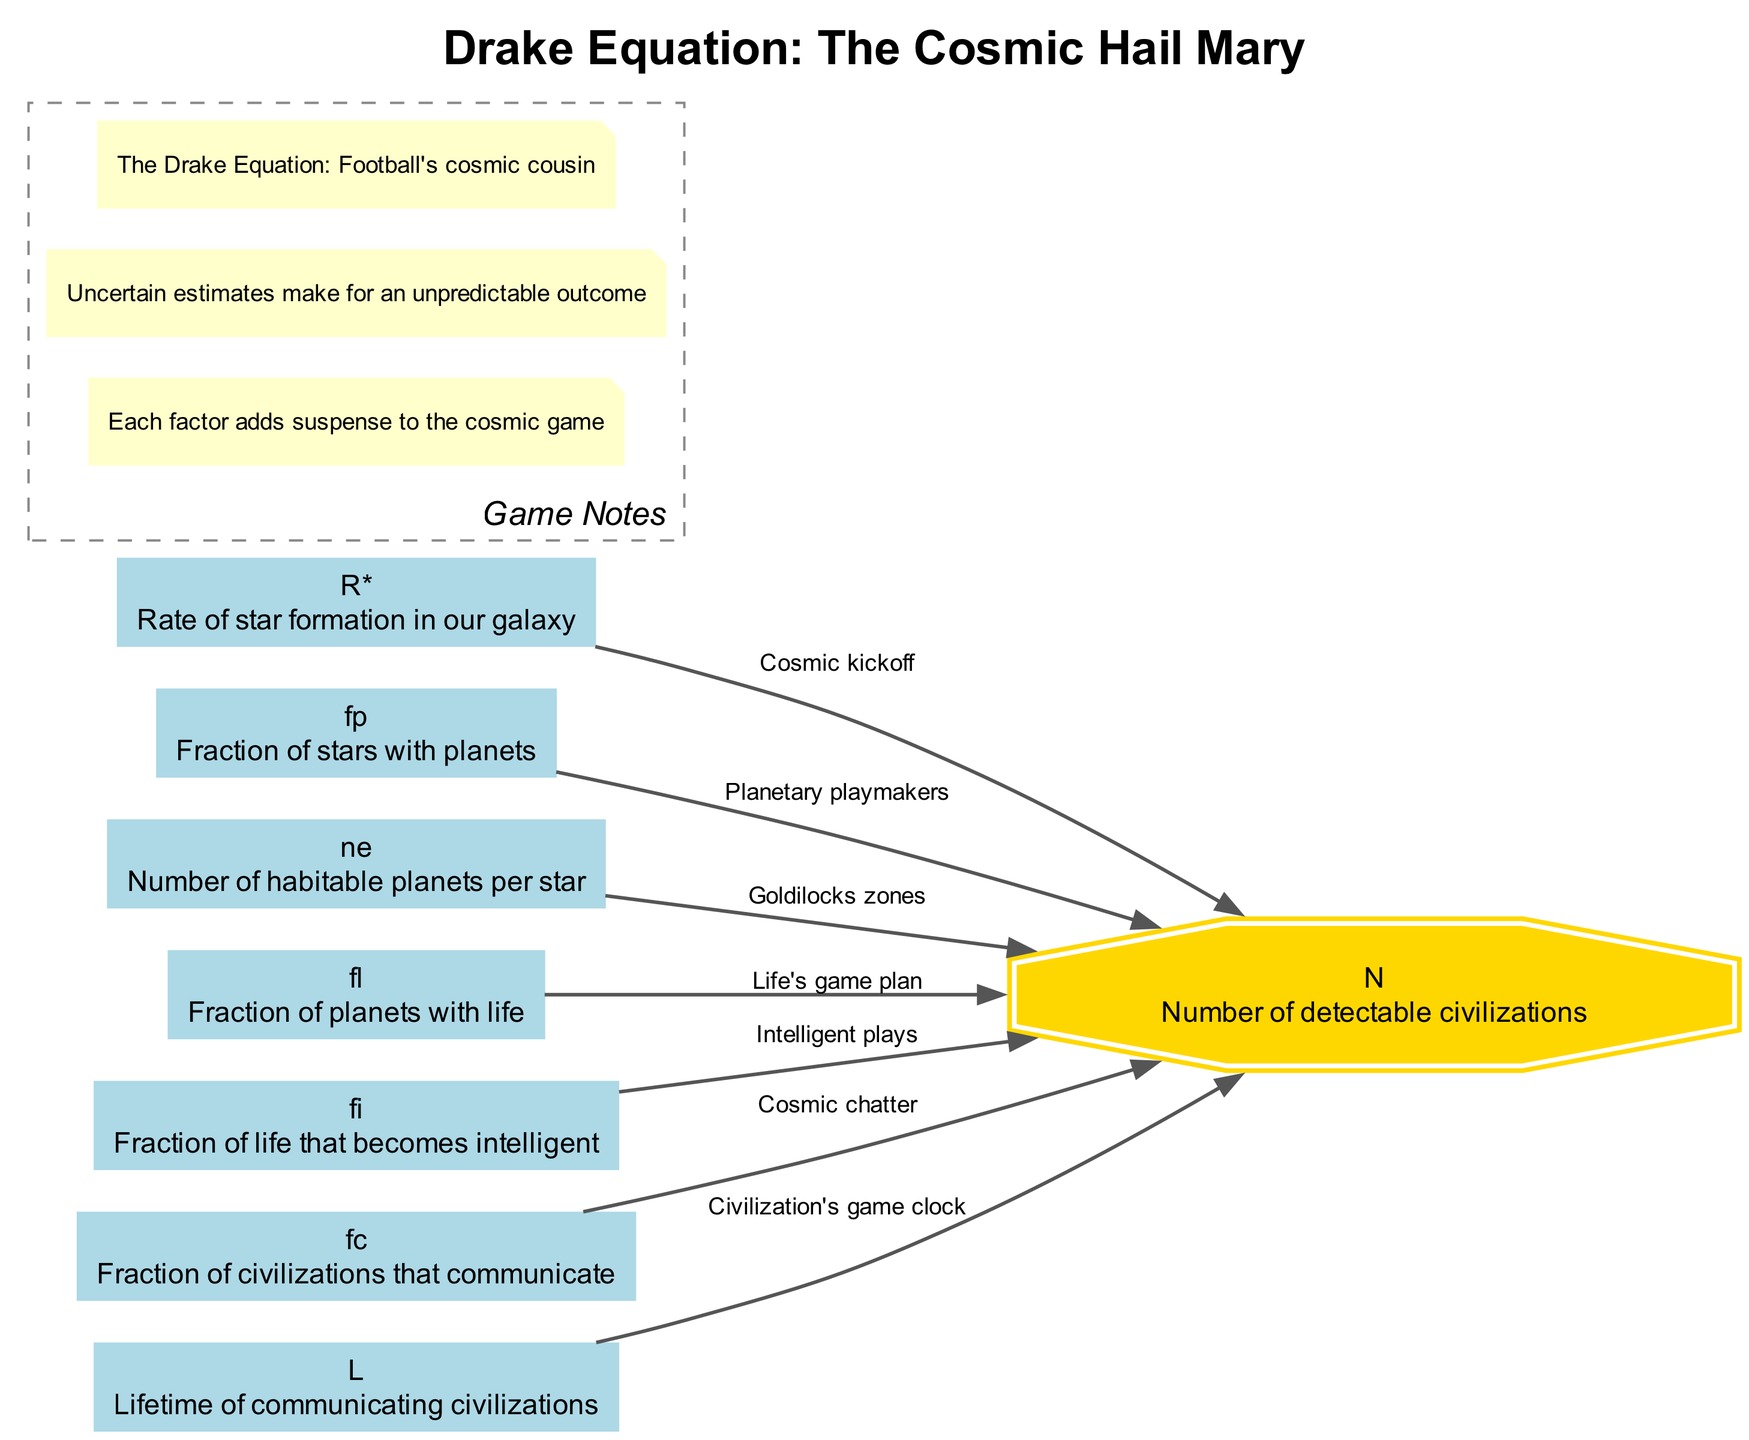What is the abbreviation for the rate of star formation in our galaxy? The diagram lists the elements, and the description for the rate of star formation is represented by "R*." It is indicated in a box on the left side of the diagram.
Answer: R* How many connections are there from the element "fp"? The diagram shows that "fp" (the fraction of stars with planets) has one directed edge leading to "N." Counting all the connections for "fp," there is only one direct link.
Answer: 1 What does "L" represent in the diagram? In the diagram, "L" stands for "Lifetime of communicating civilizations," as indicated in the description box corresponding to the node "L," showing its significance in the Drake Equation.
Answer: Lifetime of communicating civilizations What is the relationship between "fl" and "N"? The diagram has a directed edge from "fl" (fraction of planets with life) to "N" (number of detectable civilizations), labeled "Life's game plan." This connection indicates how the presence of life impacts the potential for detectable civilizations.
Answer: Life's game plan Which element has the label "Cosmic chatter"? The directed edge from the element "fc" leads to "N," and it is labeled "Cosmic chatter." This indicates that "fc," which refers to the fraction of civilizations that communicate, is linked with this label.
Answer: Cosmic chatter What is the total number of elements displayed in the diagram? By reviewing the nodes in the diagram, we observe there are a total of 8 elements listed, including "R*", "fp," "ne," "fl," "fi," "fc," "L," and "N."
Answer: 8 Which factor contributes to the 'Cosmic kickoff'? The direct label of the edge from "R*" leads to "N," indicating that it is associated with the term "Cosmic kickoff," referring to the initiation of the potential for detectable civilizations.
Answer: Cosmic kickoff Which factor's description includes "Goldilocks zones"? The node "ne," which signifies the "Number of habitable planets per star," is connected to "N" and its description includes "Goldilocks zones," indicating zones where conditions might be right for life.
Answer: Number of habitable planets per star 